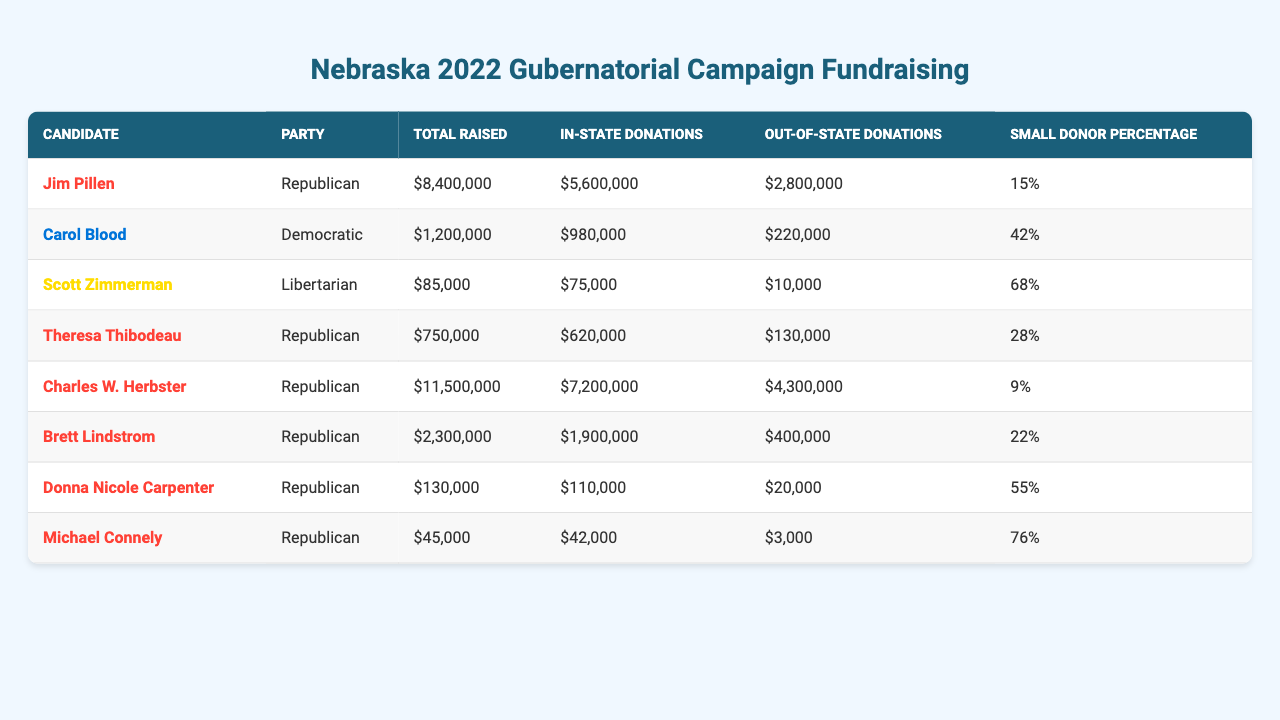What is the total amount raised by Jim Pillen? From the table, under the column "Total Raised" for Jim Pillen, the value listed is "$8,400,000."
Answer: $8,400,000 Which candidate raised the least amount of money? In the "Total Raised" column, the candidate with the lowest amount is Scott Zimmerman, with a total of "$85,000."
Answer: Scott Zimmerman What percentage of Carol Blood's donations came from small donors? The "Small Donor Percentage" for Carol Blood is listed as "42%", indicating that 42% of her donations are from small donors.
Answer: 42% How much money did Republican candidates raise in total? Summing the total raised by all Republican candidates: $8,400,000 (Pillen) + $750,000 (Thibodeau) + $11,500,000 (Herbster) + $2,300,000 (Lindstrom) + $130,000 (Carpenter) + $45,000 (Connely) = $22,125,000.
Answer: $22,125,000 Is the small donor percentage for Scott Zimmerman higher than that of Charles W. Herbster? Scott Zimmerman's small donor percentage is "68%", while Charles W. Herbster's is "9%." Since 68% is greater than 9%, the statement is true.
Answer: Yes What is the difference in total raised between the highest and lowest fundraising candidates? The highest total raised is by Charles W. Herbster at $11,500,000 and the lowest by Scott Zimmerman at $85,000. The difference is $11,500,000 - $85,000 = $11,415,000.
Answer: $11,415,000 Which party had the candidate with the highest percentage of small donors? Scott Zimmerman, a Libertarian candidate, has the highest small donor percentage of "68%," which is higher than all other candidates.
Answer: Libertarian Calculate the average total raised by Democratic candidates. The total raised by the Democratic candidate, Carol Blood, is $1,200,000. Since there is only one Democratic candidate, the average is $1,200,000.
Answer: $1,200,000 How many candidates raised more than $2 million? Examining the "Total Raised" column, Jim Pillen ($8,400,000), Charles W. Herbster ($11,500,000), and Brett Lindstrom ($2,300,000) all raised more than $2 million. This accounts for 3 candidates.
Answer: 3 Did any candidates receive more funding from out-of-state donations compared to in-state donations? By comparing the "In-State Donations" and "Out-of-State Donations" columns, Charles W. Herbster raised $4,300,000 out-of-state which is more than his in-state donations of $7,200,000, thus the statement is false.
Answer: No 